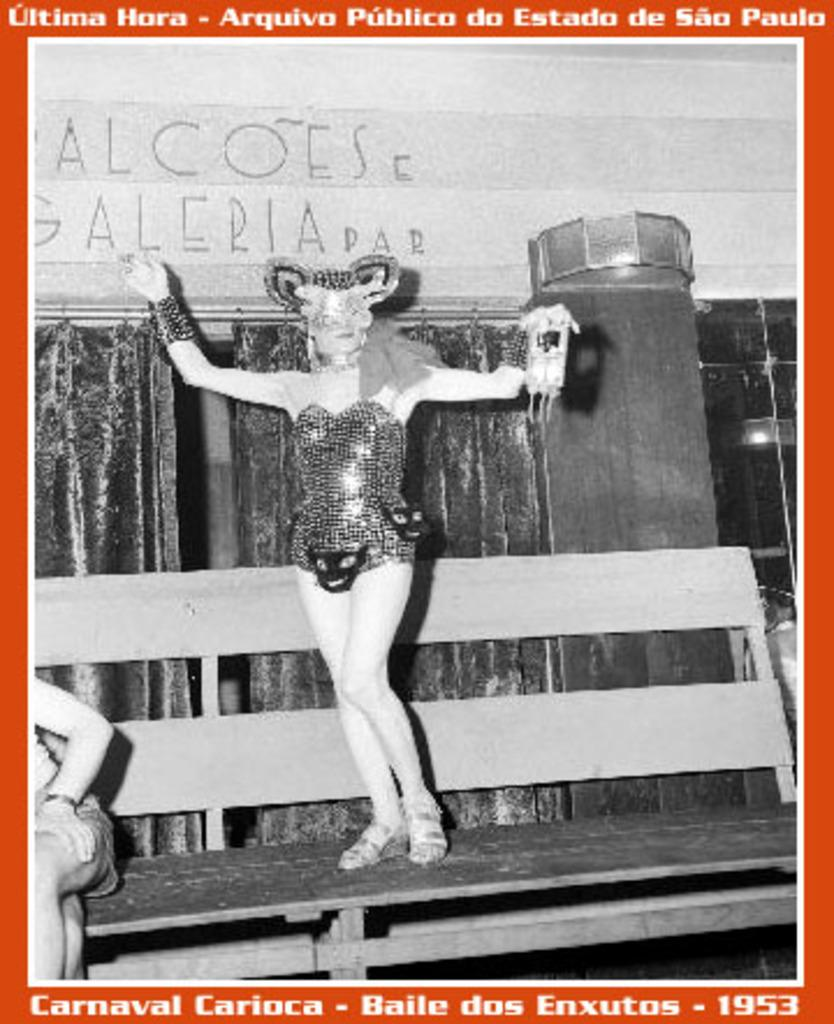What is featured in the image? There is a poster in the image. What is happening in the poster? A person is standing on a bench in the poster. What can be seen in the background of the poster? There is a curtain and a wall visible in the poster. What type of jewel is the person holding in the poster? There is no jewel visible in the poster; the person is standing on a bench. What fruit can be seen in the poster? There is no fruit present in the poster. 